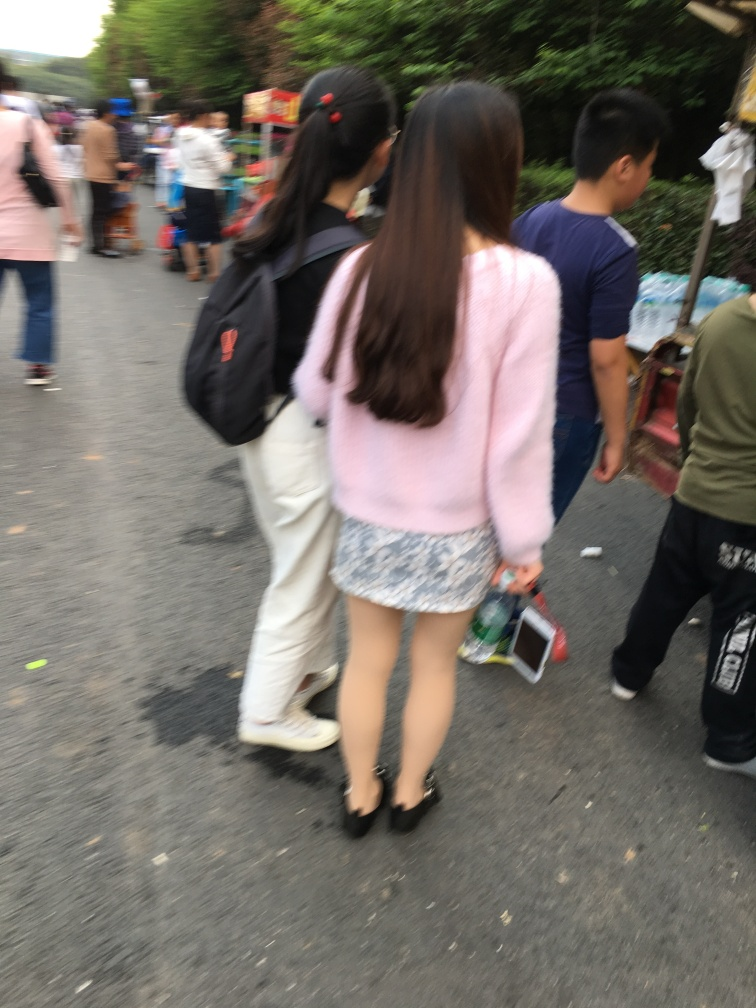What can you tell me about the setting of this photograph? The setting appears to be a bustling outdoor market or street with various individuals in casual attire, indicating a relaxed and communal atmosphere. There are stands on the side, implying the presence of vendors and the potential for street commerce. The image captures a sense of everyday life and social interaction. 